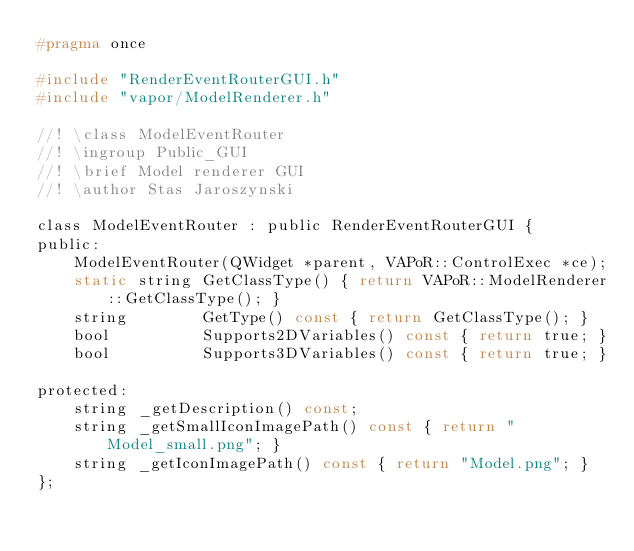<code> <loc_0><loc_0><loc_500><loc_500><_C_>#pragma once

#include "RenderEventRouterGUI.h"
#include "vapor/ModelRenderer.h"

//! \class ModelEventRouter
//! \ingroup Public_GUI
//! \brief Model renderer GUI
//! \author Stas Jaroszynski

class ModelEventRouter : public RenderEventRouterGUI {
public:
    ModelEventRouter(QWidget *parent, VAPoR::ControlExec *ce);
    static string GetClassType() { return VAPoR::ModelRenderer::GetClassType(); }
    string        GetType() const { return GetClassType(); }
    bool          Supports2DVariables() const { return true; }
    bool          Supports3DVariables() const { return true; }

protected:
    string _getDescription() const;
    string _getSmallIconImagePath() const { return "Model_small.png"; }
    string _getIconImagePath() const { return "Model.png"; }
};
</code> 